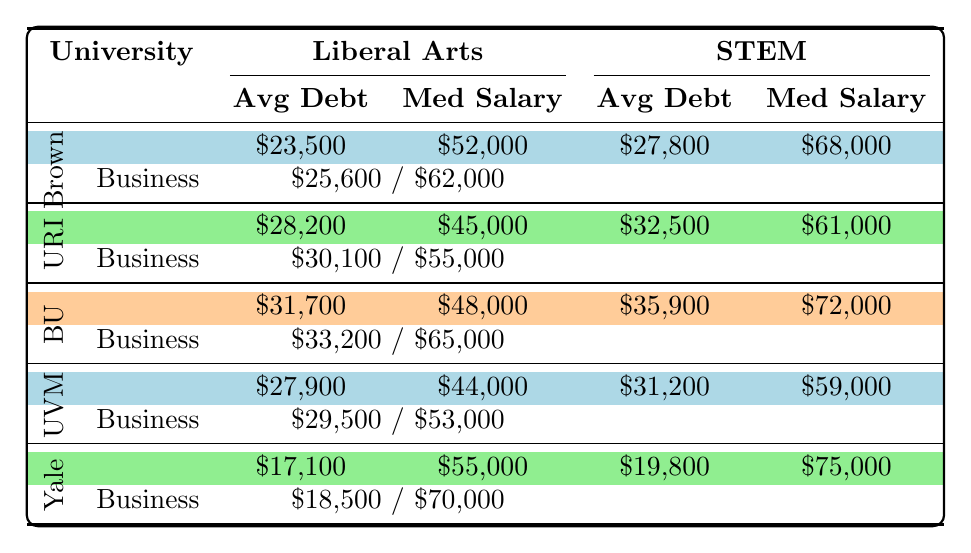What is the average debt for Liberal Arts majors at Brown University? The table shows that the average debt for Liberal Arts majors at Brown University is listed as $23,500.
Answer: $23,500 Which university has the highest average debt for STEM majors? By comparing the average debts for STEM majors across all universities, Boston University has the highest at $35,900.
Answer: Boston University What is the median starting salary for Business majors at the University of Vermont? The table indicates that the median starting salary for Business majors at the University of Vermont is $53,000.
Answer: $53,000 Is the average debt for STEM majors at Yale University less than at Brown University? The average debt for STEM majors at Yale University is $19,800, while at Brown University it is $27,800. Since $19,800 is less than $27,800, the statement is true.
Answer: Yes What is the difference in average debt between Liberal Arts majors at the University of Rhode Island and Brown University? The average debt for Liberal Arts majors at the University of Rhode Island is $28,200, and for Brown University, it is $23,500. The difference is $28,200 - $23,500 = $4,700.
Answer: $4,700 Which major at Boston University has the lowest median starting salary? The median starting salaries for majors at Boston University are $48,000 for Liberal Arts, $72,000 for STEM, and $65,000 for Business. Thus, Liberal Arts has the lowest median starting salary.
Answer: Liberal Arts What is the combined average debt for Business majors at University of Vermont and Yale University? The average debt for Business majors at University of Vermont is $29,500, and at Yale University, it is $18,500. Adding these gives $29,500 + $18,500 = $48,000.
Answer: $48,000 At which university can students expect the highest median starting salaries for STEM majors? By reviewing the table, Boston University has the highest median starting salary for STEM majors at $72,000.
Answer: Boston University Is the median starting salary for Liberal Arts majors higher at URI than at Brown University? The median starting salary for Liberal Arts majors at URI is $45,000 and at Brown University is $52,000. Since $45,000 is less, the answer is no.
Answer: No What is the average debt for Business majors at all listed universities? The average debts for Business majors are $25,600 (Brown), $30,100 (URI), $33,200 (BU), $29,500 (UVM), and $18,500 (Yale). The sum is $25,600 + $30,100 + $33,200 + $29,500 + $18,500 = $136,900, and dividing by 5 gives an average of $27,380.
Answer: $27,380 